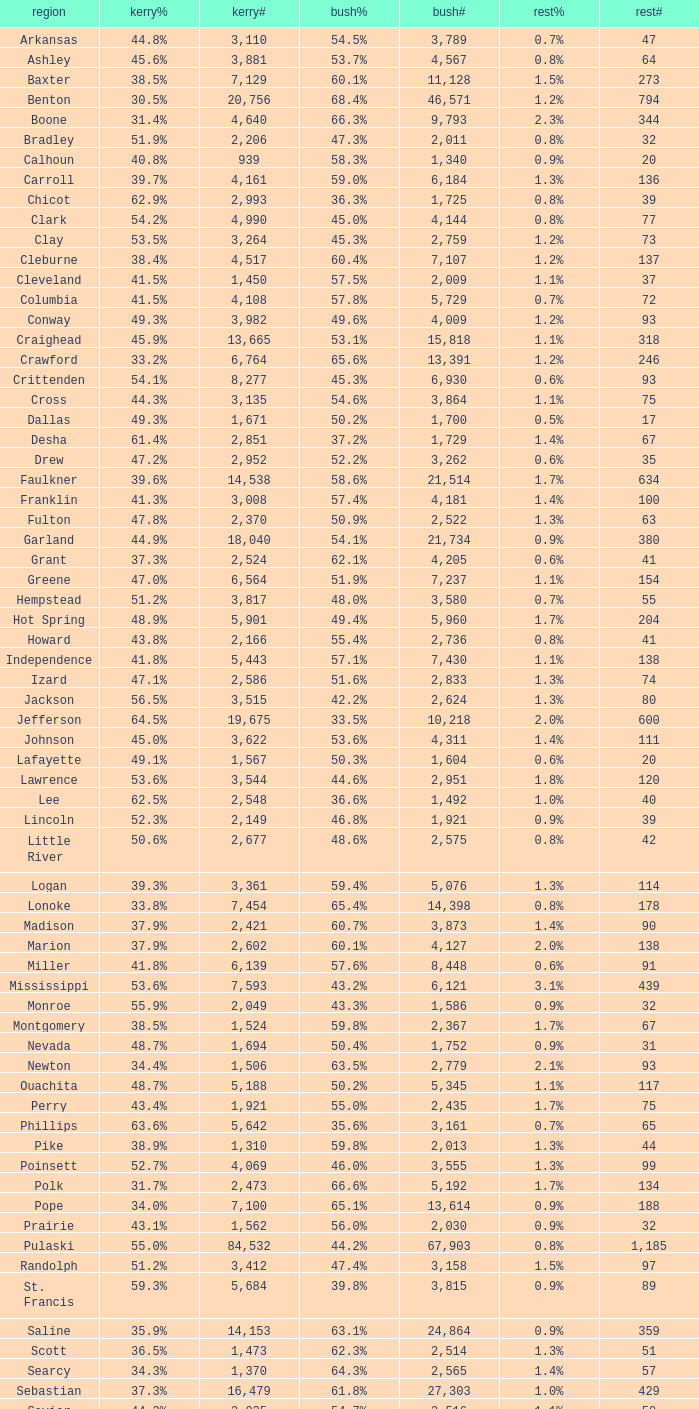What is the highest Bush#, when Others% is "1.7%", when Others# is less than 75, and when Kerry# is greater than 1,524? None. 